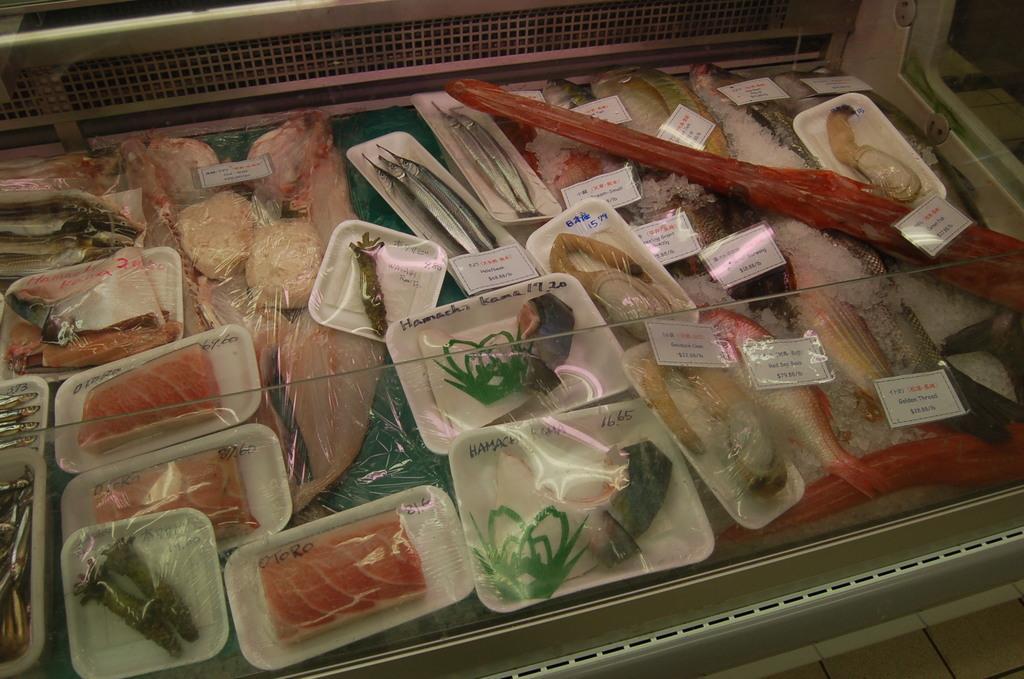Can you describe this image briefly? In this image I can see sea food packed. And I can see the stickers attached to the food. These are in the tray. And these are colorful. 